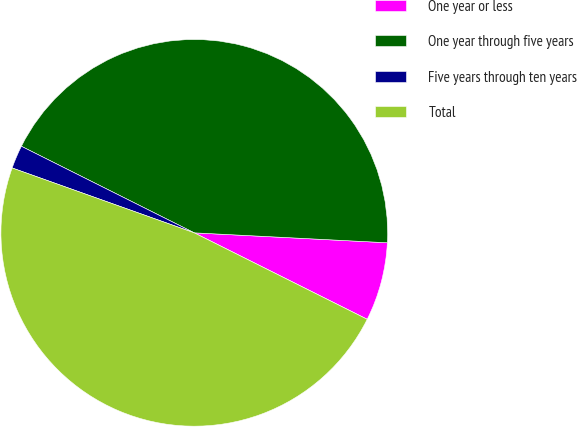Convert chart to OTSL. <chart><loc_0><loc_0><loc_500><loc_500><pie_chart><fcel>One year or less<fcel>One year through five years<fcel>Five years through ten years<fcel>Total<nl><fcel>6.56%<fcel>43.43%<fcel>1.94%<fcel>48.07%<nl></chart> 